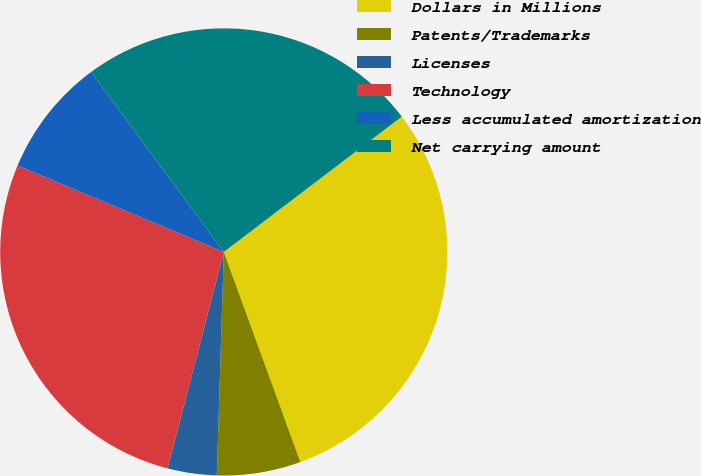Convert chart. <chart><loc_0><loc_0><loc_500><loc_500><pie_chart><fcel>Dollars in Millions<fcel>Patents/Trademarks<fcel>Licenses<fcel>Technology<fcel>Less accumulated amortization<fcel>Net carrying amount<nl><fcel>29.79%<fcel>6.06%<fcel>3.55%<fcel>27.28%<fcel>8.57%<fcel>24.77%<nl></chart> 